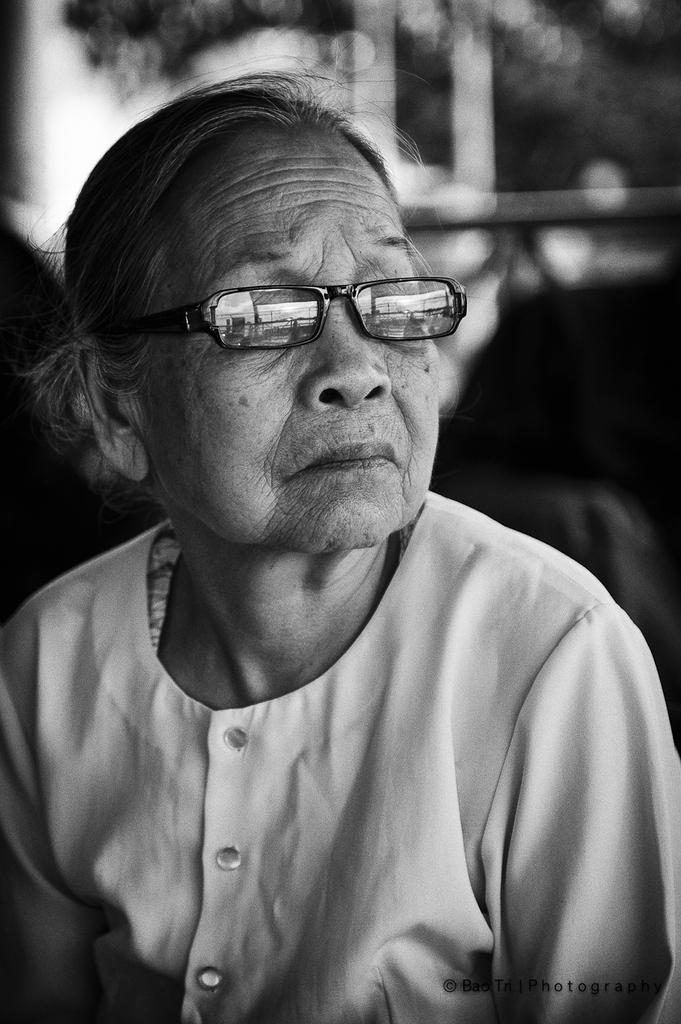Who is the main subject in the image? There is an old woman in the image. What accessory is the old woman wearing? The old woman is wearing glasses. Can you describe the background of the image? The background of the image is blurry. How many kittens are sitting on the tray in the image? There is no tray or kittens present in the image. 